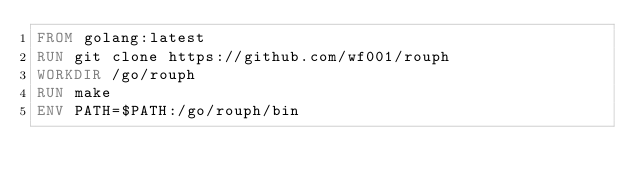Convert code to text. <code><loc_0><loc_0><loc_500><loc_500><_Dockerfile_>FROM golang:latest
RUN git clone https://github.com/wf001/rouph
WORKDIR /go/rouph
RUN make
ENV PATH=$PATH:/go/rouph/bin
</code> 